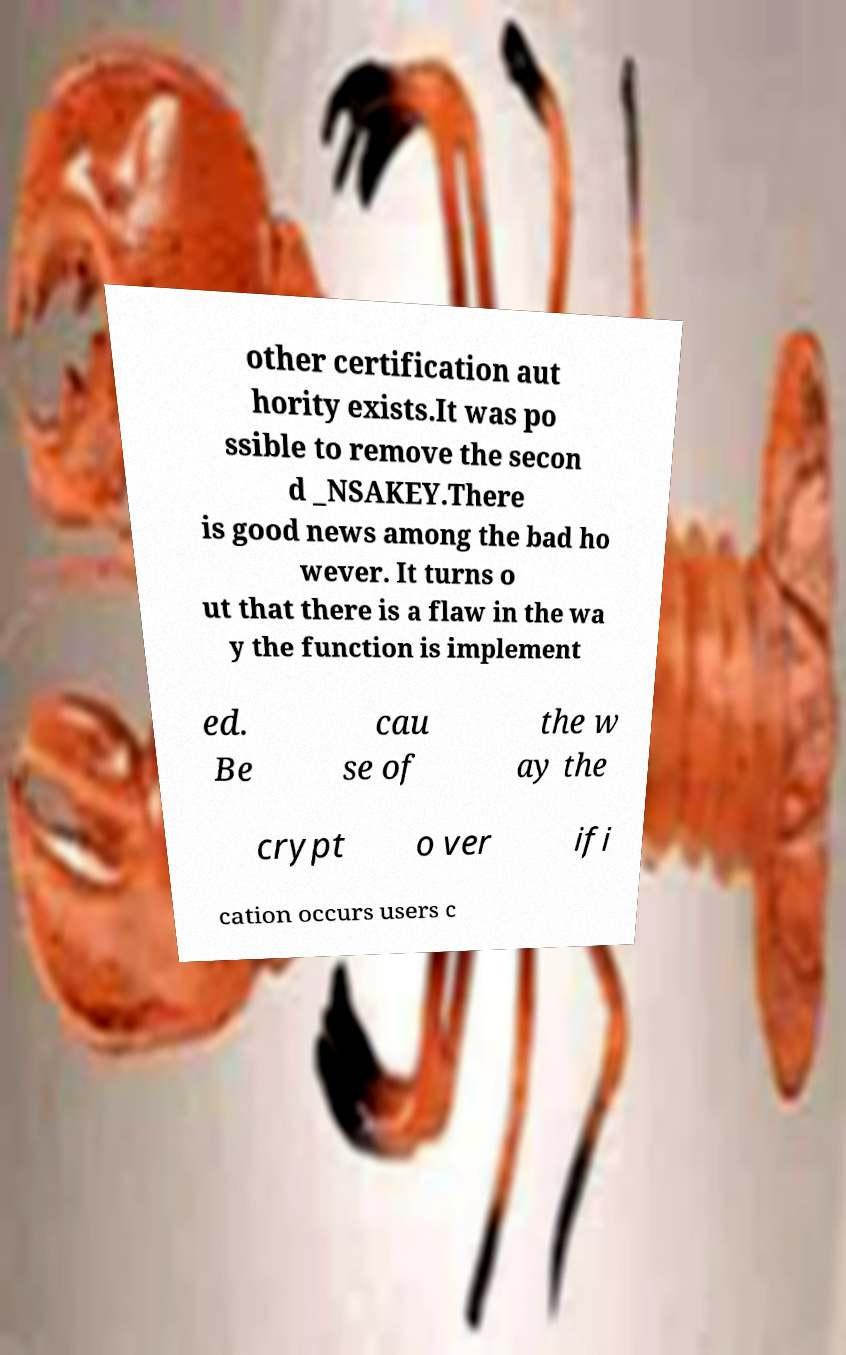Can you accurately transcribe the text from the provided image for me? other certification aut hority exists.It was po ssible to remove the secon d _NSAKEY.There is good news among the bad ho wever. It turns o ut that there is a flaw in the wa y the function is implement ed. Be cau se of the w ay the crypt o ver ifi cation occurs users c 